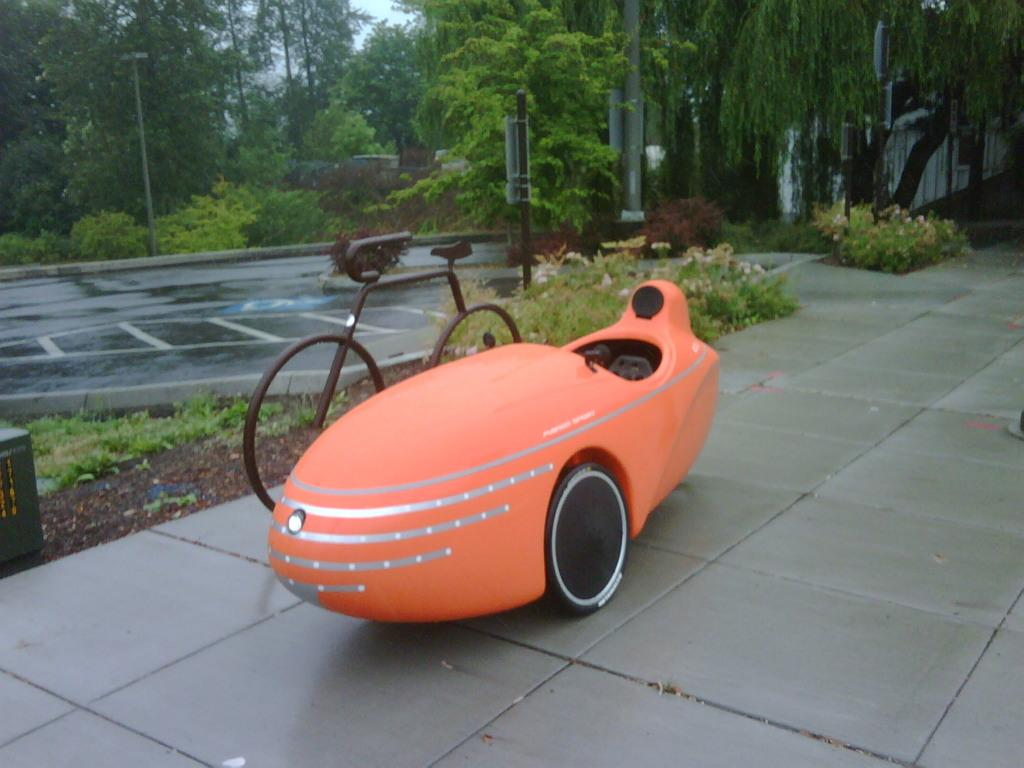What can be seen on the road in the image? There are vehicles on the road in the image. What else is visible besides the vehicles on the road? There are poles visible in the image. What is visible in the background of the image? The sky is visible in the image. What type of vegetation can be seen in the image? There are trees with green color in the image. What type of shop can be seen in the image? There is no shop present in the image. What is the chance of winning a prize in the image? There is no mention of a prize or any chance of winning in the image. 